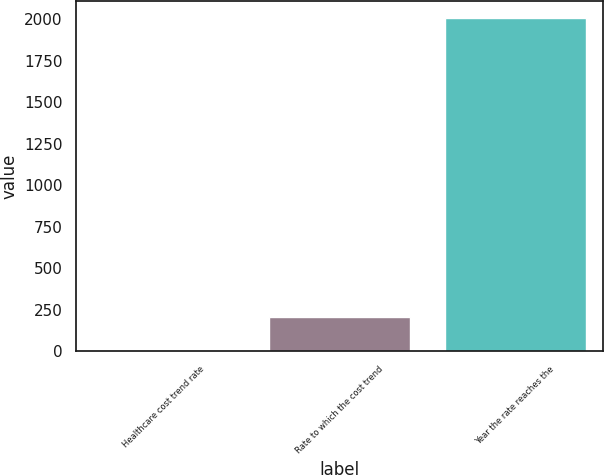<chart> <loc_0><loc_0><loc_500><loc_500><bar_chart><fcel>Healthcare cost trend rate<fcel>Rate to which the cost trend<fcel>Year the rate reaches the<nl><fcel>3<fcel>203.6<fcel>2009<nl></chart> 